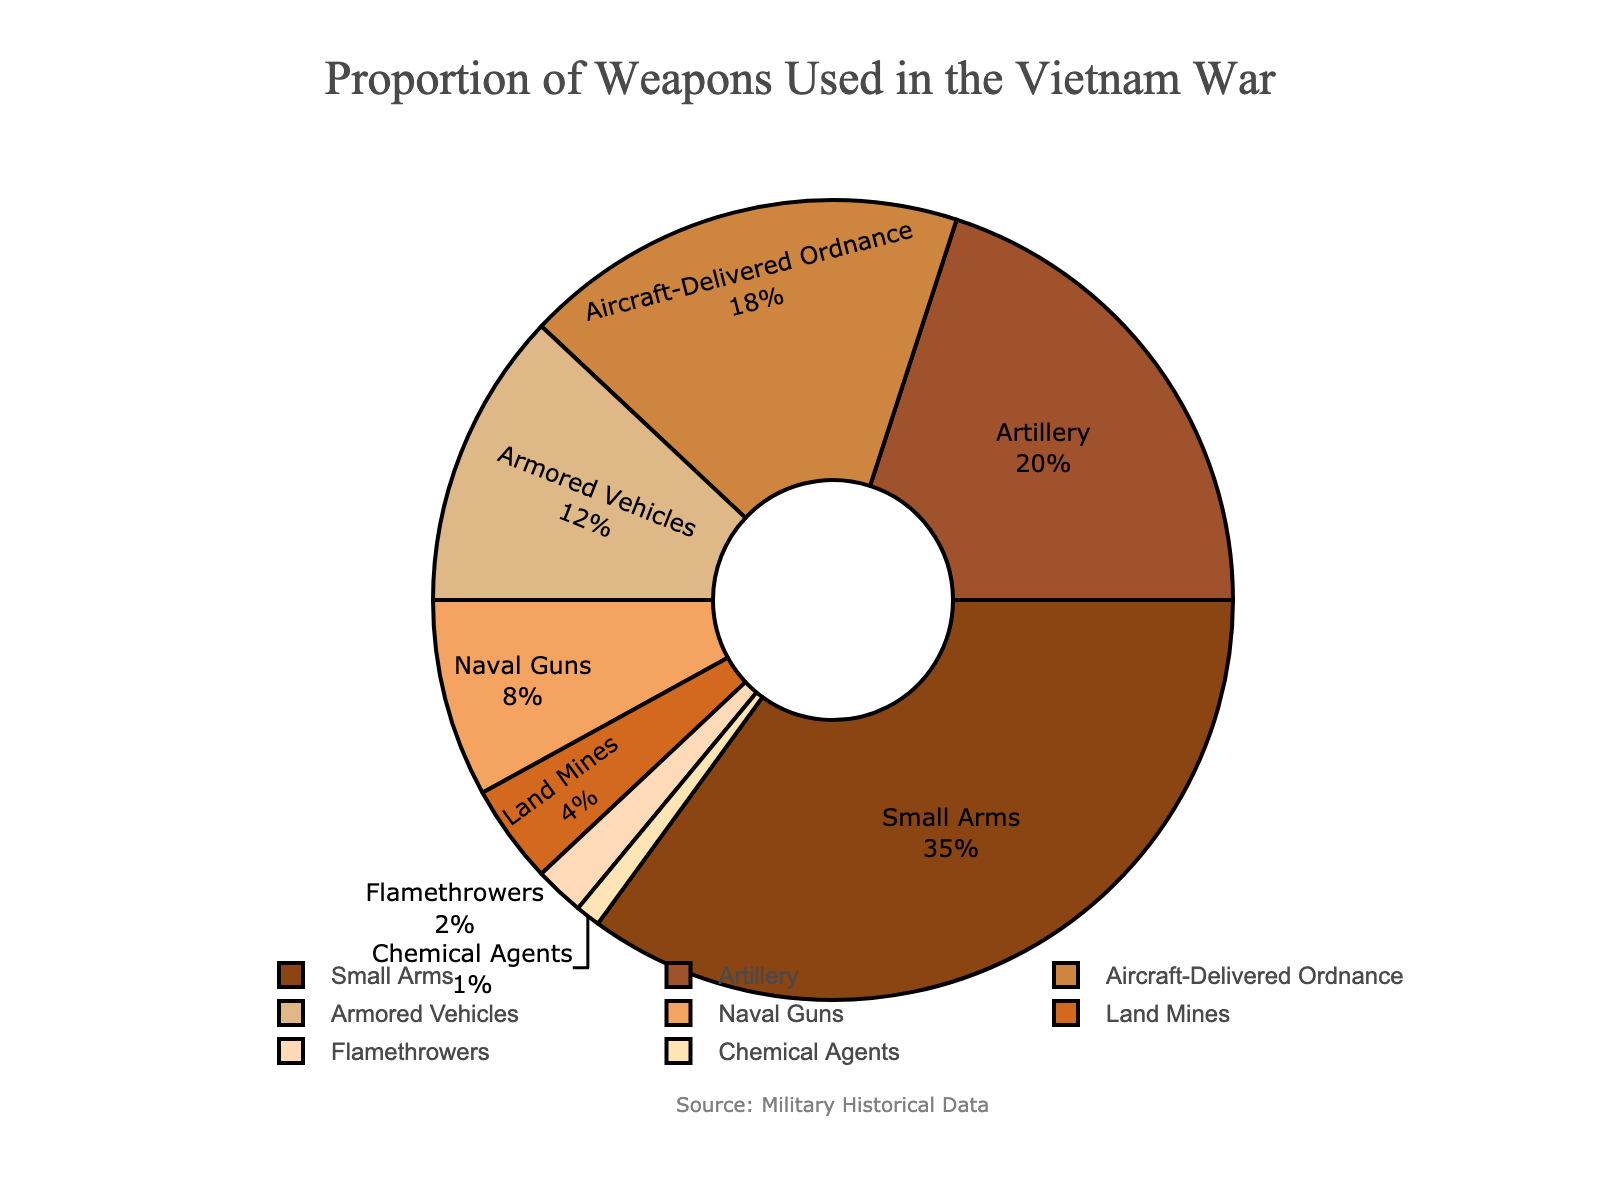Which weapon type had the highest usage? The weapon type with the highest percentage slice on the pie chart has the highest usage. The largest slice corresponds to "Small Arms," which occupies 35%.
Answer: Small Arms Which weapon type had the lowest usage? The weapon type with the smallest percentage slice on the pie chart has the lowest usage. The smallest slice corresponds to "Chemical Agents," which occupies 1%.
Answer: Chemical Agents What is the combined percentage of "Artillery" and "Naval Guns"? Add the percentages of "Artillery" and "Naval Guns" from the chart. "Artillery" is 20% and "Naval Guns" is 8%. The combined percentage is 20% + 8% = 28%.
Answer: 28% How much more usage did "Small Arms" have compared to "Flamethrowers"? Subtract the percentage of "Flamethrowers" from "Small Arms". "Small Arms" is 35% and "Flamethrowers" is 2%. The difference is 35% - 2% = 33%.
Answer: 33% Which two weapon types combined account for exactly half of the total usage, and what are their names? Identify the weapon types whose combined percentage sums up to 50%. "Small Arms" (35%) and "Artillery" (20%) add up to 35% + 20% = 55%, which is too high. Next, check smaller combinations: "Aircraft-Delivered Ordnance" (18%) and "Armored Vehicles" (12%) add up to 18% + 12% = 30% (too low), but adding "Naval Guns" (8%) results in 18% + 12% + 8% = 38% (still too low). Finally, "Small Arms" (35%) and "Land Mines" (4%) sum up to 35% + 4% = 39% (also too low). No combination equals exactly 50%.
Answer: None Of "Aircraft-Delivered Ordnance" and "Armored Vehicles," which was used more and by how much? Compare the percentages of "Aircraft-Delivered Ordnance" and "Armored Vehicles". "Aircraft-Delivered Ordnance" is 18% and "Armored Vehicles" is 12%. The difference is 18% - 12% = 6%.
Answer: Aircraft-Delivered Ordnance by 6% What percentage of weapon usage is accounted for by non-explosive weapons, assuming "Small Arms" and "Flamethrowers" are the only non-explosive types? Add the percentages of "Small Arms" and "Flamethrowers". "Small Arms" is 35% and "Flamethrowers" is 2%. The combined percentage is 35% + 2% = 37%.
Answer: 37% Which color represents the "Naval Guns" slice and how can you visually identify it? Identify the slice with the label "Naval Guns" and describe its color. The "Naval Guns" slice is colored light brown.
Answer: Light brown If "Small Arms" and "Artillery" combined were responsible for 70 engagements, how many engagements did each weapon type account for on average in these combined engagements? Assuming "Small Arms" and "Artillery" are used proportionally, compute the overall percentage first: Small Arms (35%) + Artillery (20%) = 55%. Calculate the share for each: Engagements by Small Arms = (35 / 55) * 70, Engagements by Artillery = (20 / 55) * 70. This results in approximately 44.55 for Small Arms and 25.45 for Artillery.
Answer: ~44.55 and ~25.45 